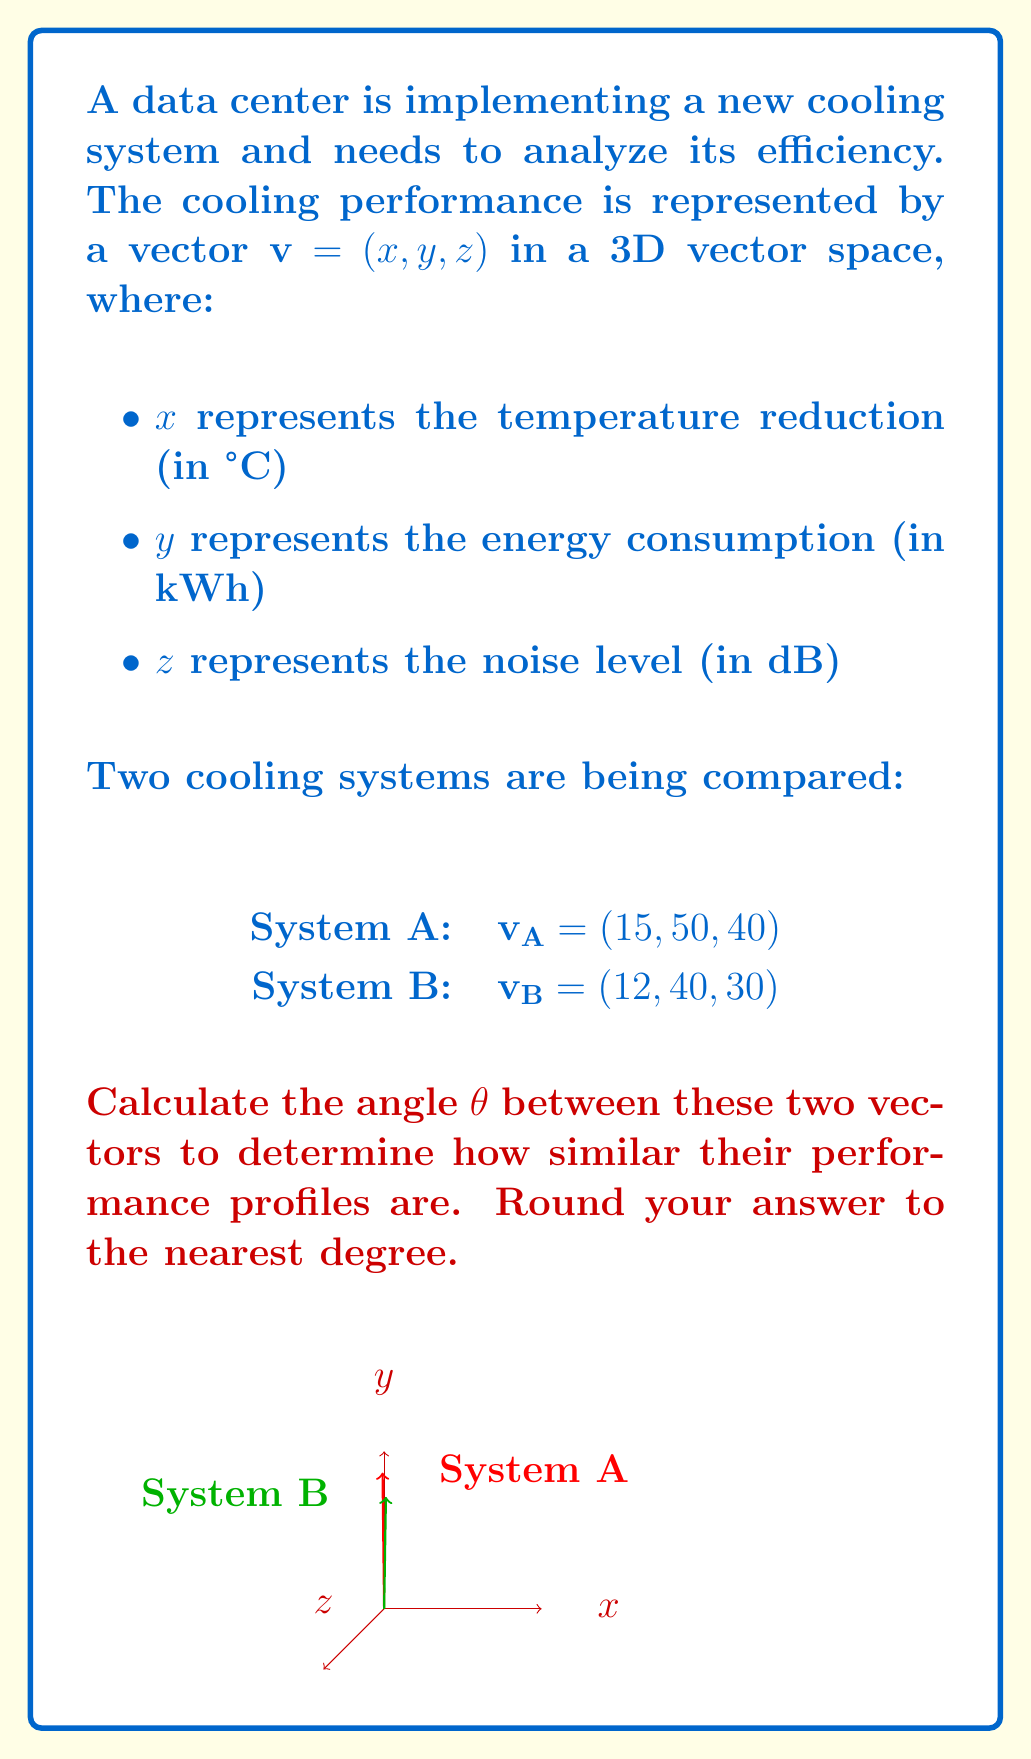Could you help me with this problem? To find the angle between two vectors in a 3D space, we can use the dot product formula:

$$\cos \theta = \frac{\mathbf{v_A} \cdot \mathbf{v_B}}{|\mathbf{v_A}| |\mathbf{v_B}|}$$

Step 1: Calculate the dot product $\mathbf{v_A} \cdot \mathbf{v_B}$
$$\mathbf{v_A} \cdot \mathbf{v_B} = 15(12) + 50(40) + 40(30) = 180 + 2000 + 1200 = 3380$$

Step 2: Calculate the magnitudes of $\mathbf{v_A}$ and $\mathbf{v_B}$
$$|\mathbf{v_A}| = \sqrt{15^2 + 50^2 + 40^2} = \sqrt{225 + 2500 + 1600} = \sqrt{4325} \approx 65.76$$
$$|\mathbf{v_B}| = \sqrt{12^2 + 40^2 + 30^2} = \sqrt{144 + 1600 + 900} = \sqrt{2644} \approx 51.42$$

Step 3: Apply the dot product formula
$$\cos \theta = \frac{3380}{65.76 \times 51.42} \approx 0.9998$$

Step 4: Take the inverse cosine (arccos) and convert to degrees
$$\theta = \arccos(0.9998) \approx 0.0200 \text{ radians}$$
$$\theta \approx 0.0200 \times \frac{180°}{\pi} \approx 1.15°$$

Step 5: Round to the nearest degree
$$\theta \approx 1°$$
Answer: 1° 